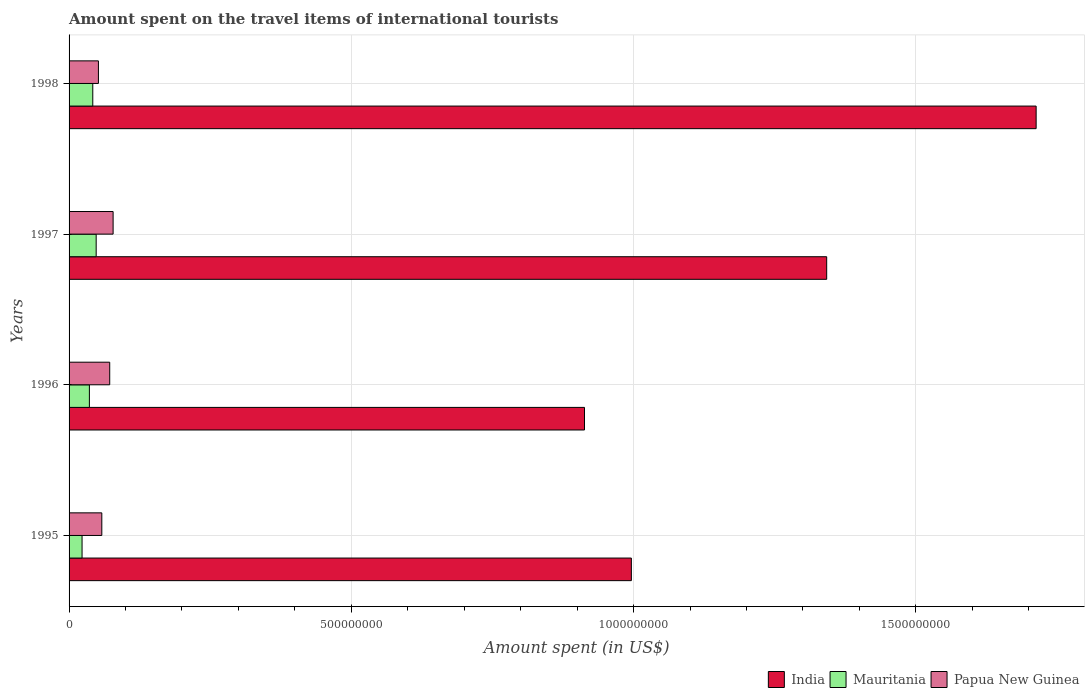How many different coloured bars are there?
Provide a short and direct response. 3. How many groups of bars are there?
Provide a short and direct response. 4. Are the number of bars per tick equal to the number of legend labels?
Make the answer very short. Yes. Are the number of bars on each tick of the Y-axis equal?
Provide a short and direct response. Yes. What is the label of the 1st group of bars from the top?
Ensure brevity in your answer.  1998. In how many cases, is the number of bars for a given year not equal to the number of legend labels?
Your answer should be compact. 0. What is the amount spent on the travel items of international tourists in Papua New Guinea in 1996?
Your answer should be compact. 7.20e+07. Across all years, what is the maximum amount spent on the travel items of international tourists in Papua New Guinea?
Make the answer very short. 7.80e+07. Across all years, what is the minimum amount spent on the travel items of international tourists in India?
Provide a short and direct response. 9.13e+08. In which year was the amount spent on the travel items of international tourists in Papua New Guinea minimum?
Provide a succinct answer. 1998. What is the total amount spent on the travel items of international tourists in India in the graph?
Give a very brief answer. 4.96e+09. What is the difference between the amount spent on the travel items of international tourists in Mauritania in 1996 and that in 1998?
Give a very brief answer. -6.00e+06. What is the difference between the amount spent on the travel items of international tourists in Papua New Guinea in 1998 and the amount spent on the travel items of international tourists in India in 1995?
Offer a terse response. -9.44e+08. What is the average amount spent on the travel items of international tourists in India per year?
Your response must be concise. 1.24e+09. In the year 1998, what is the difference between the amount spent on the travel items of international tourists in Papua New Guinea and amount spent on the travel items of international tourists in Mauritania?
Give a very brief answer. 1.00e+07. What is the ratio of the amount spent on the travel items of international tourists in Papua New Guinea in 1995 to that in 1998?
Give a very brief answer. 1.12. Is the amount spent on the travel items of international tourists in Mauritania in 1995 less than that in 1996?
Keep it short and to the point. Yes. What is the difference between the highest and the lowest amount spent on the travel items of international tourists in Papua New Guinea?
Keep it short and to the point. 2.60e+07. What does the 2nd bar from the top in 1997 represents?
Make the answer very short. Mauritania. What does the 3rd bar from the bottom in 1997 represents?
Offer a terse response. Papua New Guinea. What is the difference between two consecutive major ticks on the X-axis?
Ensure brevity in your answer.  5.00e+08. Does the graph contain any zero values?
Provide a succinct answer. No. Does the graph contain grids?
Make the answer very short. Yes. Where does the legend appear in the graph?
Your answer should be very brief. Bottom right. What is the title of the graph?
Make the answer very short. Amount spent on the travel items of international tourists. What is the label or title of the X-axis?
Your answer should be compact. Amount spent (in US$). What is the label or title of the Y-axis?
Your answer should be compact. Years. What is the Amount spent (in US$) in India in 1995?
Provide a short and direct response. 9.96e+08. What is the Amount spent (in US$) in Mauritania in 1995?
Provide a short and direct response. 2.30e+07. What is the Amount spent (in US$) in Papua New Guinea in 1995?
Make the answer very short. 5.80e+07. What is the Amount spent (in US$) in India in 1996?
Offer a very short reply. 9.13e+08. What is the Amount spent (in US$) in Mauritania in 1996?
Your answer should be very brief. 3.60e+07. What is the Amount spent (in US$) of Papua New Guinea in 1996?
Provide a succinct answer. 7.20e+07. What is the Amount spent (in US$) in India in 1997?
Your answer should be very brief. 1.34e+09. What is the Amount spent (in US$) in Mauritania in 1997?
Your answer should be very brief. 4.80e+07. What is the Amount spent (in US$) in Papua New Guinea in 1997?
Your answer should be very brief. 7.80e+07. What is the Amount spent (in US$) of India in 1998?
Offer a very short reply. 1.71e+09. What is the Amount spent (in US$) in Mauritania in 1998?
Make the answer very short. 4.20e+07. What is the Amount spent (in US$) of Papua New Guinea in 1998?
Give a very brief answer. 5.20e+07. Across all years, what is the maximum Amount spent (in US$) in India?
Offer a terse response. 1.71e+09. Across all years, what is the maximum Amount spent (in US$) of Mauritania?
Your answer should be compact. 4.80e+07. Across all years, what is the maximum Amount spent (in US$) in Papua New Guinea?
Your answer should be very brief. 7.80e+07. Across all years, what is the minimum Amount spent (in US$) of India?
Your response must be concise. 9.13e+08. Across all years, what is the minimum Amount spent (in US$) of Mauritania?
Your response must be concise. 2.30e+07. Across all years, what is the minimum Amount spent (in US$) of Papua New Guinea?
Your response must be concise. 5.20e+07. What is the total Amount spent (in US$) of India in the graph?
Provide a succinct answer. 4.96e+09. What is the total Amount spent (in US$) in Mauritania in the graph?
Your response must be concise. 1.49e+08. What is the total Amount spent (in US$) of Papua New Guinea in the graph?
Your answer should be compact. 2.60e+08. What is the difference between the Amount spent (in US$) in India in 1995 and that in 1996?
Offer a very short reply. 8.30e+07. What is the difference between the Amount spent (in US$) of Mauritania in 1995 and that in 1996?
Provide a short and direct response. -1.30e+07. What is the difference between the Amount spent (in US$) in Papua New Guinea in 1995 and that in 1996?
Your response must be concise. -1.40e+07. What is the difference between the Amount spent (in US$) in India in 1995 and that in 1997?
Your response must be concise. -3.46e+08. What is the difference between the Amount spent (in US$) of Mauritania in 1995 and that in 1997?
Give a very brief answer. -2.50e+07. What is the difference between the Amount spent (in US$) in Papua New Guinea in 1995 and that in 1997?
Offer a terse response. -2.00e+07. What is the difference between the Amount spent (in US$) in India in 1995 and that in 1998?
Your answer should be compact. -7.17e+08. What is the difference between the Amount spent (in US$) of Mauritania in 1995 and that in 1998?
Keep it short and to the point. -1.90e+07. What is the difference between the Amount spent (in US$) in India in 1996 and that in 1997?
Provide a succinct answer. -4.29e+08. What is the difference between the Amount spent (in US$) in Mauritania in 1996 and that in 1997?
Your response must be concise. -1.20e+07. What is the difference between the Amount spent (in US$) in Papua New Guinea in 1996 and that in 1997?
Provide a short and direct response. -6.00e+06. What is the difference between the Amount spent (in US$) in India in 1996 and that in 1998?
Your answer should be compact. -8.00e+08. What is the difference between the Amount spent (in US$) in Mauritania in 1996 and that in 1998?
Provide a short and direct response. -6.00e+06. What is the difference between the Amount spent (in US$) of Papua New Guinea in 1996 and that in 1998?
Your response must be concise. 2.00e+07. What is the difference between the Amount spent (in US$) in India in 1997 and that in 1998?
Your answer should be compact. -3.71e+08. What is the difference between the Amount spent (in US$) in Papua New Guinea in 1997 and that in 1998?
Make the answer very short. 2.60e+07. What is the difference between the Amount spent (in US$) of India in 1995 and the Amount spent (in US$) of Mauritania in 1996?
Your answer should be compact. 9.60e+08. What is the difference between the Amount spent (in US$) in India in 1995 and the Amount spent (in US$) in Papua New Guinea in 1996?
Your response must be concise. 9.24e+08. What is the difference between the Amount spent (in US$) of Mauritania in 1995 and the Amount spent (in US$) of Papua New Guinea in 1996?
Your answer should be compact. -4.90e+07. What is the difference between the Amount spent (in US$) of India in 1995 and the Amount spent (in US$) of Mauritania in 1997?
Offer a terse response. 9.48e+08. What is the difference between the Amount spent (in US$) of India in 1995 and the Amount spent (in US$) of Papua New Guinea in 1997?
Provide a short and direct response. 9.18e+08. What is the difference between the Amount spent (in US$) of Mauritania in 1995 and the Amount spent (in US$) of Papua New Guinea in 1997?
Keep it short and to the point. -5.50e+07. What is the difference between the Amount spent (in US$) of India in 1995 and the Amount spent (in US$) of Mauritania in 1998?
Your answer should be very brief. 9.54e+08. What is the difference between the Amount spent (in US$) in India in 1995 and the Amount spent (in US$) in Papua New Guinea in 1998?
Provide a succinct answer. 9.44e+08. What is the difference between the Amount spent (in US$) in Mauritania in 1995 and the Amount spent (in US$) in Papua New Guinea in 1998?
Provide a short and direct response. -2.90e+07. What is the difference between the Amount spent (in US$) in India in 1996 and the Amount spent (in US$) in Mauritania in 1997?
Make the answer very short. 8.65e+08. What is the difference between the Amount spent (in US$) in India in 1996 and the Amount spent (in US$) in Papua New Guinea in 1997?
Your answer should be compact. 8.35e+08. What is the difference between the Amount spent (in US$) in Mauritania in 1996 and the Amount spent (in US$) in Papua New Guinea in 1997?
Ensure brevity in your answer.  -4.20e+07. What is the difference between the Amount spent (in US$) in India in 1996 and the Amount spent (in US$) in Mauritania in 1998?
Make the answer very short. 8.71e+08. What is the difference between the Amount spent (in US$) in India in 1996 and the Amount spent (in US$) in Papua New Guinea in 1998?
Your response must be concise. 8.61e+08. What is the difference between the Amount spent (in US$) in Mauritania in 1996 and the Amount spent (in US$) in Papua New Guinea in 1998?
Offer a terse response. -1.60e+07. What is the difference between the Amount spent (in US$) in India in 1997 and the Amount spent (in US$) in Mauritania in 1998?
Provide a short and direct response. 1.30e+09. What is the difference between the Amount spent (in US$) in India in 1997 and the Amount spent (in US$) in Papua New Guinea in 1998?
Provide a succinct answer. 1.29e+09. What is the average Amount spent (in US$) in India per year?
Your response must be concise. 1.24e+09. What is the average Amount spent (in US$) in Mauritania per year?
Keep it short and to the point. 3.72e+07. What is the average Amount spent (in US$) in Papua New Guinea per year?
Ensure brevity in your answer.  6.50e+07. In the year 1995, what is the difference between the Amount spent (in US$) in India and Amount spent (in US$) in Mauritania?
Ensure brevity in your answer.  9.73e+08. In the year 1995, what is the difference between the Amount spent (in US$) of India and Amount spent (in US$) of Papua New Guinea?
Offer a terse response. 9.38e+08. In the year 1995, what is the difference between the Amount spent (in US$) in Mauritania and Amount spent (in US$) in Papua New Guinea?
Your answer should be very brief. -3.50e+07. In the year 1996, what is the difference between the Amount spent (in US$) in India and Amount spent (in US$) in Mauritania?
Keep it short and to the point. 8.77e+08. In the year 1996, what is the difference between the Amount spent (in US$) in India and Amount spent (in US$) in Papua New Guinea?
Provide a succinct answer. 8.41e+08. In the year 1996, what is the difference between the Amount spent (in US$) in Mauritania and Amount spent (in US$) in Papua New Guinea?
Your response must be concise. -3.60e+07. In the year 1997, what is the difference between the Amount spent (in US$) in India and Amount spent (in US$) in Mauritania?
Give a very brief answer. 1.29e+09. In the year 1997, what is the difference between the Amount spent (in US$) of India and Amount spent (in US$) of Papua New Guinea?
Your response must be concise. 1.26e+09. In the year 1997, what is the difference between the Amount spent (in US$) in Mauritania and Amount spent (in US$) in Papua New Guinea?
Provide a short and direct response. -3.00e+07. In the year 1998, what is the difference between the Amount spent (in US$) of India and Amount spent (in US$) of Mauritania?
Your answer should be very brief. 1.67e+09. In the year 1998, what is the difference between the Amount spent (in US$) in India and Amount spent (in US$) in Papua New Guinea?
Ensure brevity in your answer.  1.66e+09. In the year 1998, what is the difference between the Amount spent (in US$) in Mauritania and Amount spent (in US$) in Papua New Guinea?
Keep it short and to the point. -1.00e+07. What is the ratio of the Amount spent (in US$) of Mauritania in 1995 to that in 1996?
Give a very brief answer. 0.64. What is the ratio of the Amount spent (in US$) of Papua New Guinea in 1995 to that in 1996?
Your response must be concise. 0.81. What is the ratio of the Amount spent (in US$) of India in 1995 to that in 1997?
Give a very brief answer. 0.74. What is the ratio of the Amount spent (in US$) of Mauritania in 1995 to that in 1997?
Your answer should be compact. 0.48. What is the ratio of the Amount spent (in US$) in Papua New Guinea in 1995 to that in 1997?
Give a very brief answer. 0.74. What is the ratio of the Amount spent (in US$) of India in 1995 to that in 1998?
Make the answer very short. 0.58. What is the ratio of the Amount spent (in US$) of Mauritania in 1995 to that in 1998?
Provide a short and direct response. 0.55. What is the ratio of the Amount spent (in US$) in Papua New Guinea in 1995 to that in 1998?
Make the answer very short. 1.12. What is the ratio of the Amount spent (in US$) in India in 1996 to that in 1997?
Provide a short and direct response. 0.68. What is the ratio of the Amount spent (in US$) in Mauritania in 1996 to that in 1997?
Ensure brevity in your answer.  0.75. What is the ratio of the Amount spent (in US$) in Papua New Guinea in 1996 to that in 1997?
Provide a short and direct response. 0.92. What is the ratio of the Amount spent (in US$) in India in 1996 to that in 1998?
Your answer should be compact. 0.53. What is the ratio of the Amount spent (in US$) in Papua New Guinea in 1996 to that in 1998?
Provide a succinct answer. 1.38. What is the ratio of the Amount spent (in US$) in India in 1997 to that in 1998?
Give a very brief answer. 0.78. What is the ratio of the Amount spent (in US$) of Papua New Guinea in 1997 to that in 1998?
Offer a very short reply. 1.5. What is the difference between the highest and the second highest Amount spent (in US$) in India?
Offer a very short reply. 3.71e+08. What is the difference between the highest and the second highest Amount spent (in US$) of Papua New Guinea?
Keep it short and to the point. 6.00e+06. What is the difference between the highest and the lowest Amount spent (in US$) of India?
Your answer should be compact. 8.00e+08. What is the difference between the highest and the lowest Amount spent (in US$) of Mauritania?
Provide a short and direct response. 2.50e+07. What is the difference between the highest and the lowest Amount spent (in US$) in Papua New Guinea?
Your answer should be compact. 2.60e+07. 